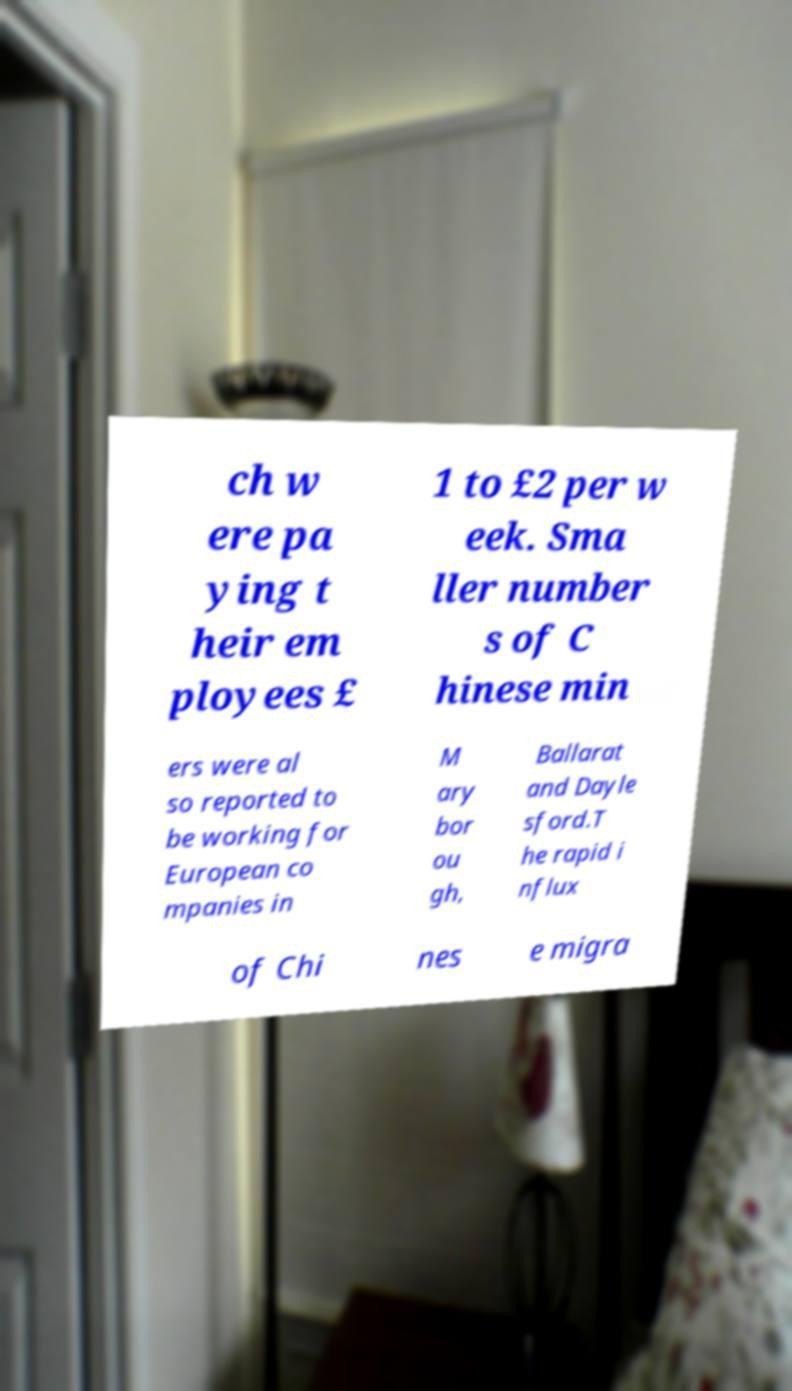For documentation purposes, I need the text within this image transcribed. Could you provide that? ch w ere pa ying t heir em ployees £ 1 to £2 per w eek. Sma ller number s of C hinese min ers were al so reported to be working for European co mpanies in M ary bor ou gh, Ballarat and Dayle sford.T he rapid i nflux of Chi nes e migra 